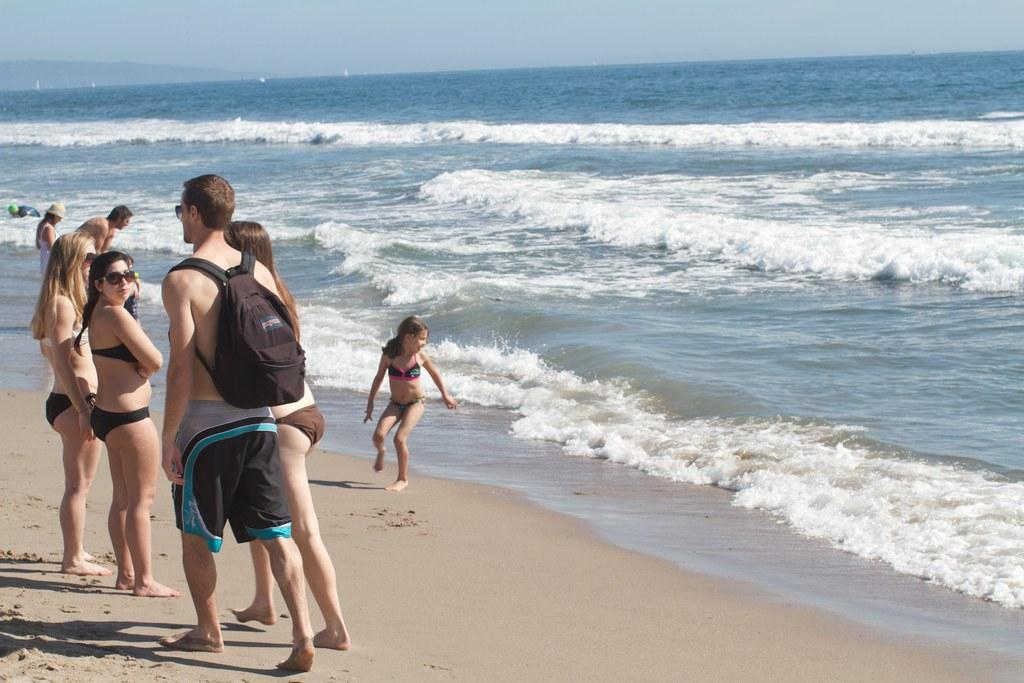What is the surface that the persons are standing on in the image? The persons are standing on sand in the left corner of the image. What is located in front of the persons? There is water in front of the persons. What type of mint can be seen growing near the persons in the image? There is no mint present in the image; it features persons standing on sand with water in front of them. 